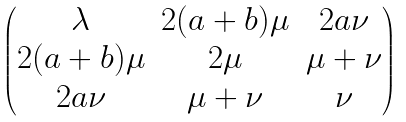Convert formula to latex. <formula><loc_0><loc_0><loc_500><loc_500>\begin{pmatrix} \lambda & 2 ( a + b ) \mu & 2 a \nu \\ 2 ( a + b ) \mu & 2 \mu & \mu + \nu \\ 2 a \nu & \mu + \nu & \nu \end{pmatrix}</formula> 